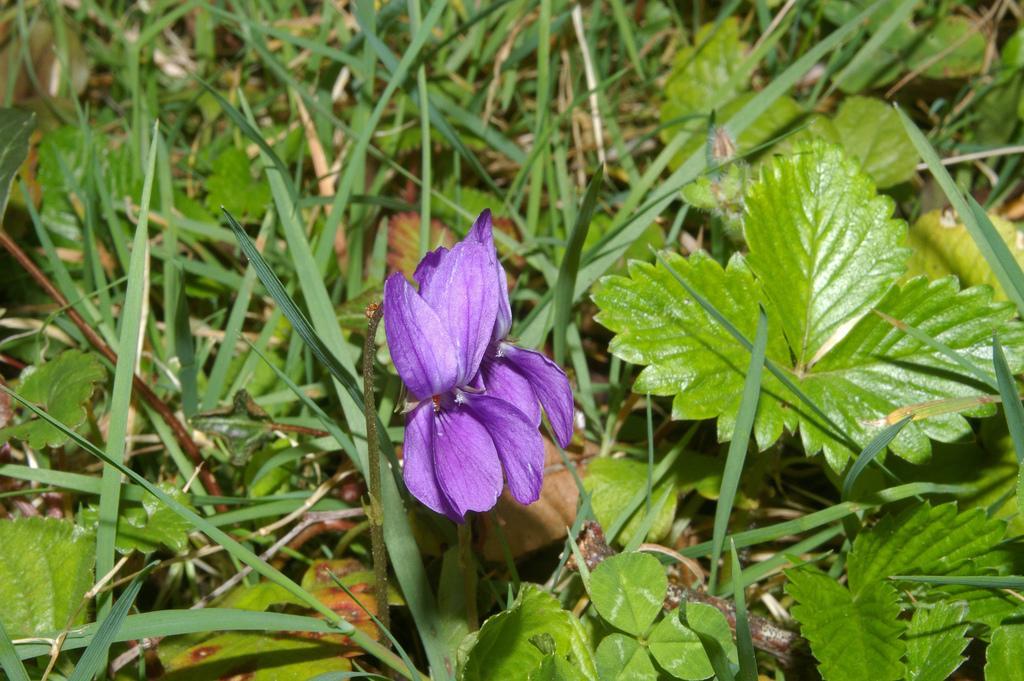Can you describe this image briefly? In this picture there is a purple color flower in the center of the image and there are small plants around the area of the image. 